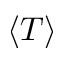<formula> <loc_0><loc_0><loc_500><loc_500>\langle T \rangle</formula> 